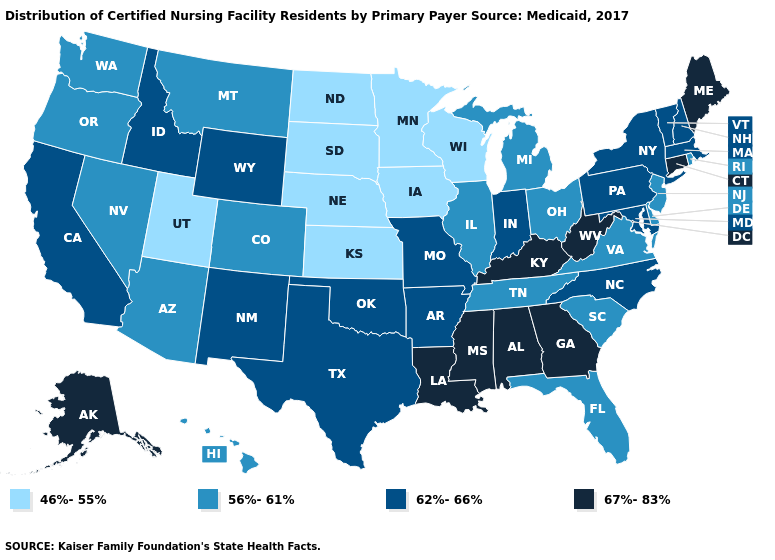Name the states that have a value in the range 56%-61%?
Keep it brief. Arizona, Colorado, Delaware, Florida, Hawaii, Illinois, Michigan, Montana, Nevada, New Jersey, Ohio, Oregon, Rhode Island, South Carolina, Tennessee, Virginia, Washington. What is the value of North Carolina?
Be succinct. 62%-66%. Name the states that have a value in the range 56%-61%?
Concise answer only. Arizona, Colorado, Delaware, Florida, Hawaii, Illinois, Michigan, Montana, Nevada, New Jersey, Ohio, Oregon, Rhode Island, South Carolina, Tennessee, Virginia, Washington. What is the lowest value in states that border California?
Answer briefly. 56%-61%. Does Montana have the same value as New Jersey?
Be succinct. Yes. Name the states that have a value in the range 67%-83%?
Concise answer only. Alabama, Alaska, Connecticut, Georgia, Kentucky, Louisiana, Maine, Mississippi, West Virginia. Which states have the lowest value in the USA?
Keep it brief. Iowa, Kansas, Minnesota, Nebraska, North Dakota, South Dakota, Utah, Wisconsin. What is the lowest value in the South?
Write a very short answer. 56%-61%. Name the states that have a value in the range 46%-55%?
Answer briefly. Iowa, Kansas, Minnesota, Nebraska, North Dakota, South Dakota, Utah, Wisconsin. Which states have the highest value in the USA?
Concise answer only. Alabama, Alaska, Connecticut, Georgia, Kentucky, Louisiana, Maine, Mississippi, West Virginia. Does Maryland have the lowest value in the South?
Write a very short answer. No. What is the lowest value in the USA?
Give a very brief answer. 46%-55%. Name the states that have a value in the range 46%-55%?
Write a very short answer. Iowa, Kansas, Minnesota, Nebraska, North Dakota, South Dakota, Utah, Wisconsin. Name the states that have a value in the range 67%-83%?
Short answer required. Alabama, Alaska, Connecticut, Georgia, Kentucky, Louisiana, Maine, Mississippi, West Virginia. 